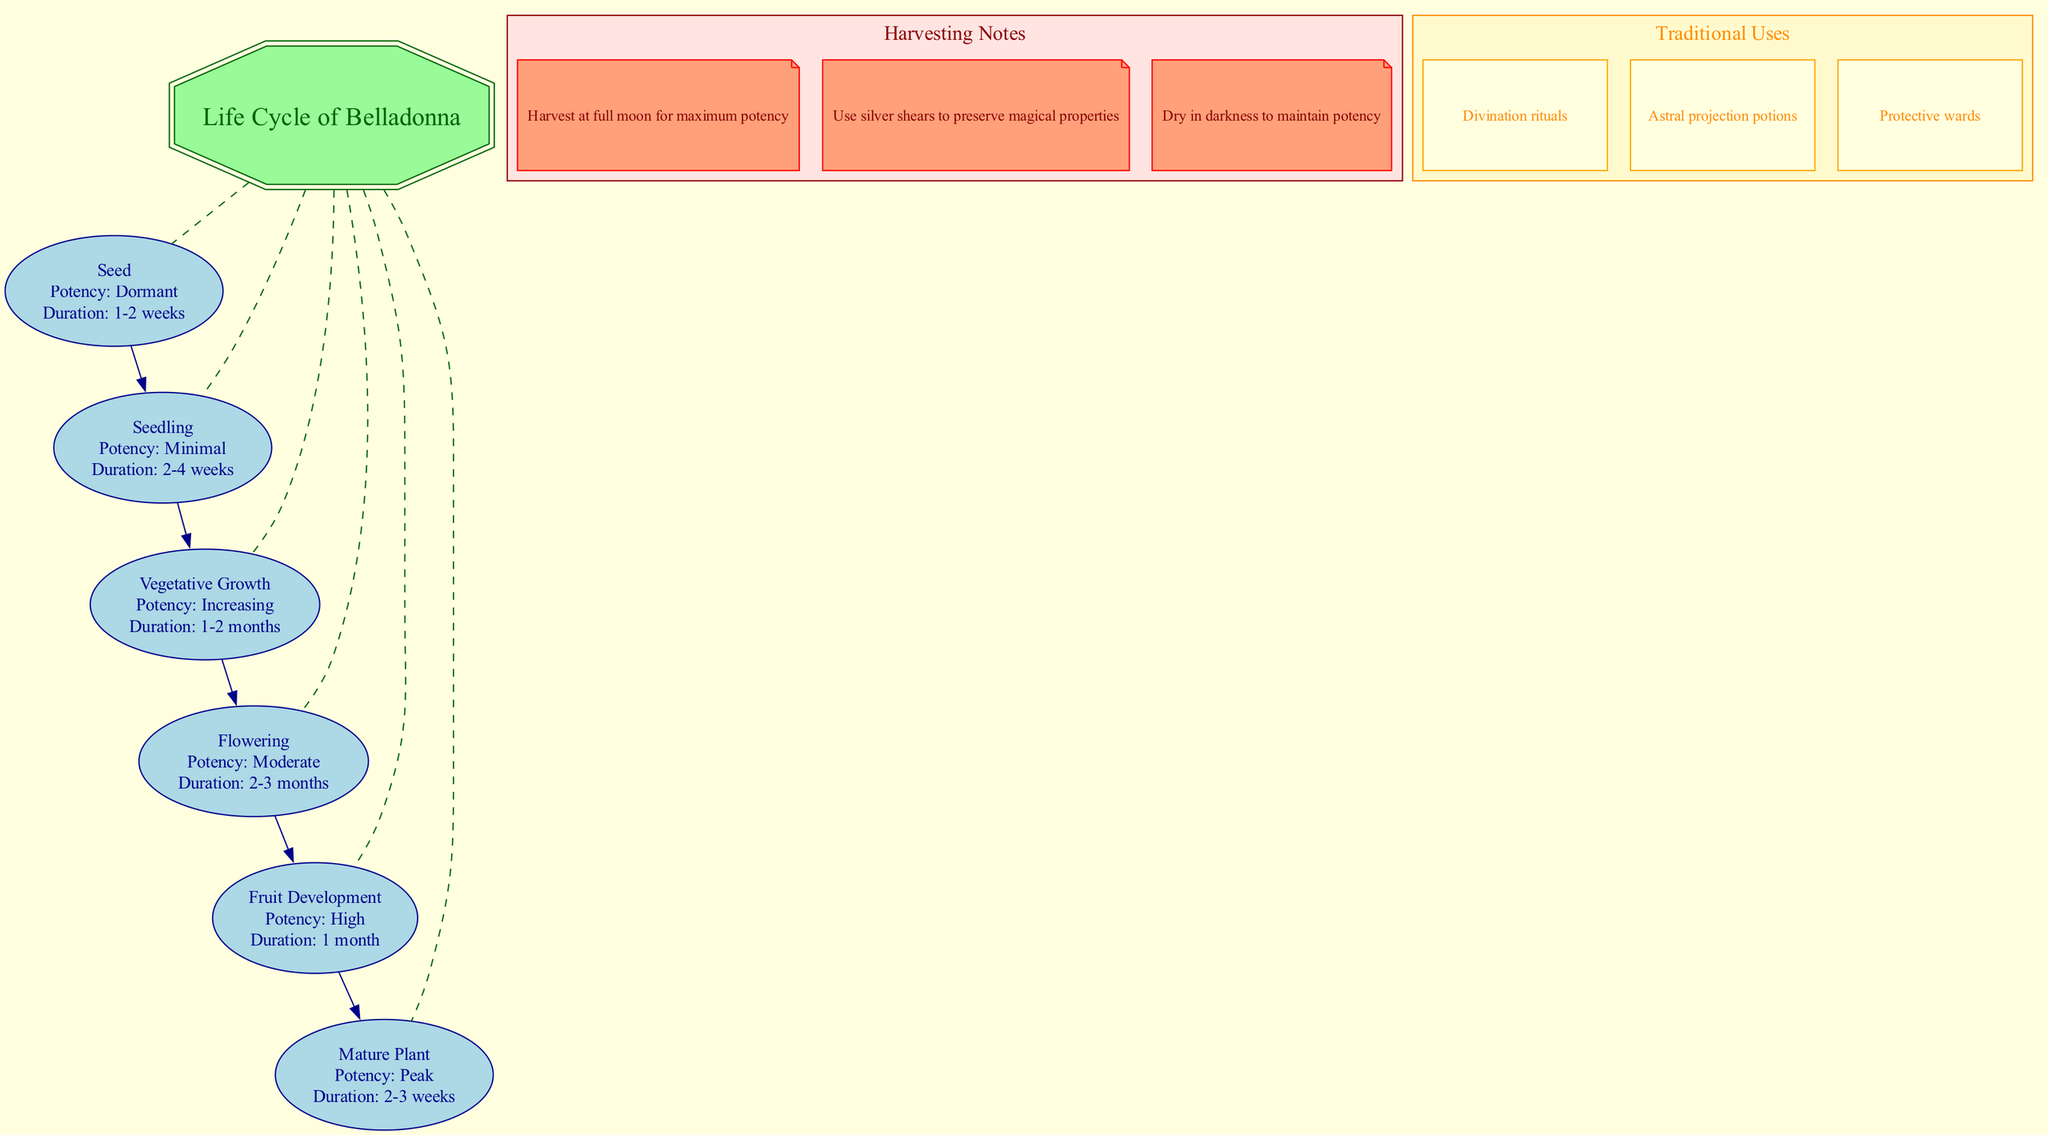What is the potency of the Seed stage? The diagram states that the potency of the Seed stage is "Dormant." This information is clearly mentioned in the node for this stage.
Answer: Dormant How long does the Flowering stage last? The diagram specifies that the duration of the Flowering stage is "2-3 months," which is noted within the respective node for this stage.
Answer: 2-3 months What is the last stage before the Mature Plant? By observing the flow of the diagram, the last stage before reaching the Mature Plant is the "Fruit Development." The edges connecting the nodes indicate the order of the stages.
Answer: Fruit Development How many harvesting notes are provided in the diagram? The diagram lists three harvesting notes in the designated subgraph area. Counting these notes yields the total number.
Answer: 3 Which stage has the highest potency? By examining the potency values associated with each stage in the diagram, the "Mature Plant" stage is identified as having the potency labeled as "Peak."
Answer: Peak What harvesting note specifies a tool type? Among the harvesting notes, the one instructing to "Use silver shears to preserve magical properties" mentions a specific tool, which can be easily identified.
Answer: Silver shears What is a traditional use of Belladonna? The diagram provides multiple traditional uses, and one example given is "Divination rituals," which corresponds to one of the nodes in the traditional uses subgraph.
Answer: Divination rituals Which stage has an increasing potency? The diagram shows that the "Vegetative Growth" stage is associated with the potency labeled "Increasing," as indicated in the corresponding node.
Answer: Increasing What color scheme is used for the central node? The central node adopts a color scheme of dark green for the outline and pale green for the fill, clearly specified in the diagram attributes.
Answer: Dark green and pale green 